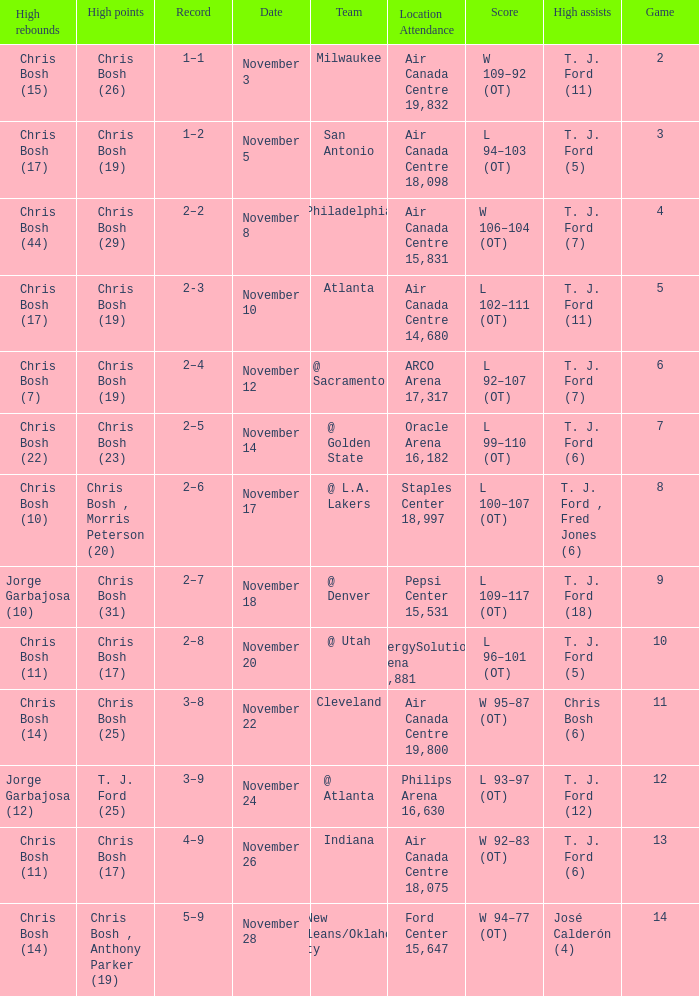Where was the game on November 20? EnergySolutions Arena 18,881. 